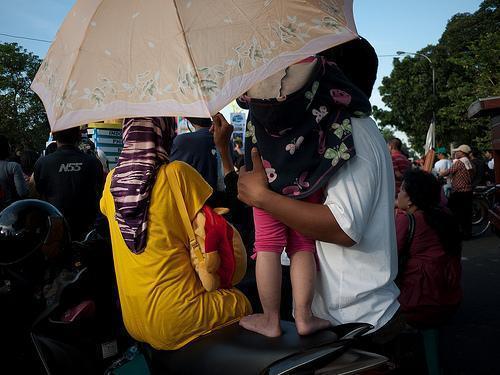How many people are sharing the umbrella?
Give a very brief answer. 3. 